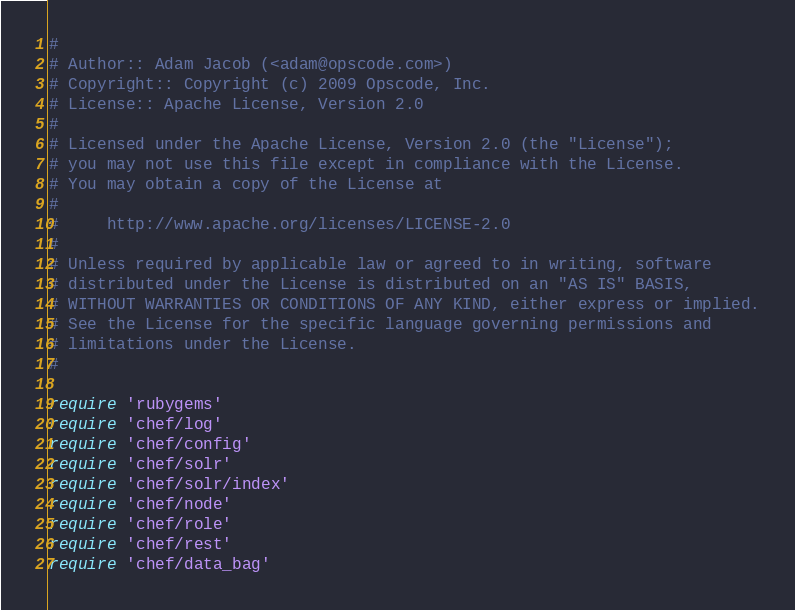<code> <loc_0><loc_0><loc_500><loc_500><_Ruby_>#
# Author:: Adam Jacob (<adam@opscode.com>)
# Copyright:: Copyright (c) 2009 Opscode, Inc.
# License:: Apache License, Version 2.0
#
# Licensed under the Apache License, Version 2.0 (the "License");
# you may not use this file except in compliance with the License.
# You may obtain a copy of the License at
# 
#     http://www.apache.org/licenses/LICENSE-2.0
# 
# Unless required by applicable law or agreed to in writing, software
# distributed under the License is distributed on an "AS IS" BASIS,
# WITHOUT WARRANTIES OR CONDITIONS OF ANY KIND, either express or implied.
# See the License for the specific language governing permissions and
# limitations under the License.
#

require 'rubygems'
require 'chef/log'
require 'chef/config'
require 'chef/solr'
require 'chef/solr/index'
require 'chef/node'
require 'chef/role'
require 'chef/rest'
require 'chef/data_bag'</code> 